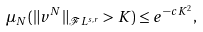<formula> <loc_0><loc_0><loc_500><loc_500>\mu _ { N } ( \| v ^ { N } \| _ { \mathcal { F } L ^ { s , r } } > K ) \leq e ^ { - c K ^ { 2 } } ,</formula> 